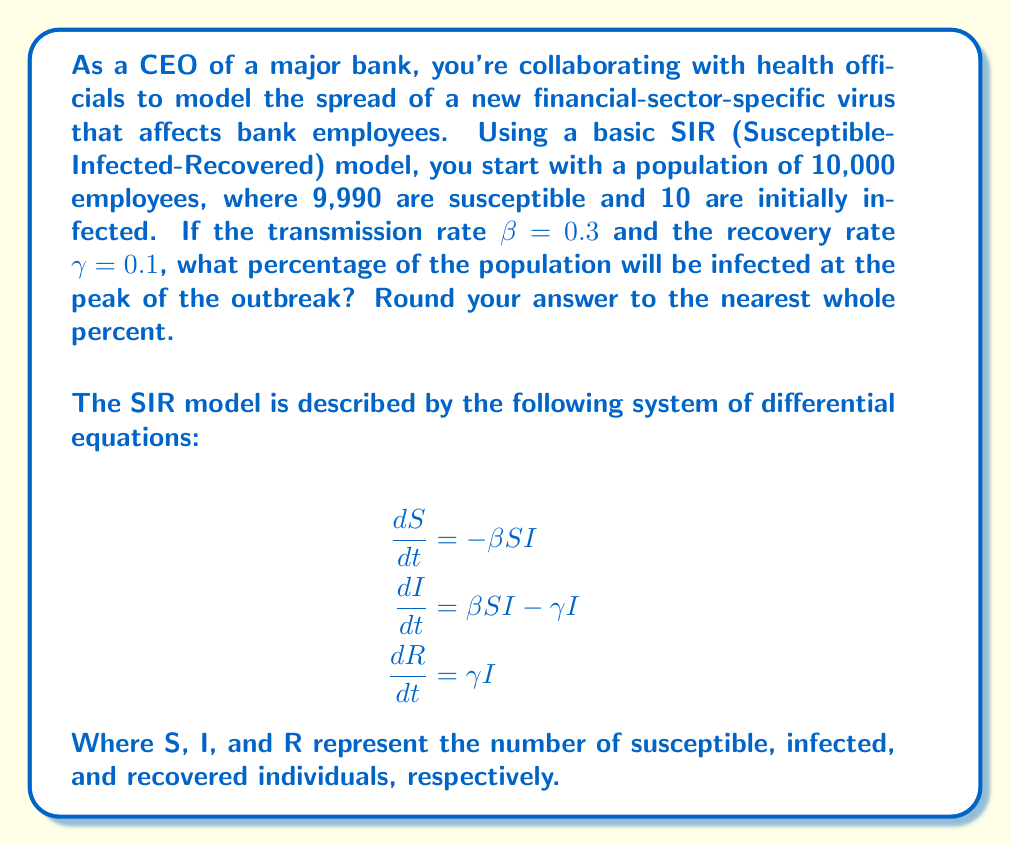Help me with this question. To solve this problem, we'll follow these steps:

1) First, we need to calculate the basic reproduction number R₀:
   $$R_0 = \frac{\beta}{\gamma} = \frac{0.3}{0.1} = 3$$

2) In an SIR model, the peak of the outbreak occurs when the number of susceptible individuals reaches the threshold S_t:
   $$S_t = \frac{N}{R_0} = \frac{10,000}{3} \approx 3,333.33$$

3) At this point, the number of infected individuals is at its maximum. We can calculate this using the conservation of population:
   $$N = S + I + R$$
   $$I_{max} = N - S_t - R$$

4) To find R, we use the fact that at the peak, the rate of change of infected individuals is zero:
   $$\frac{dI}{dt} = \beta SI - \gamma I = 0$$
   $$\beta S_t = \gamma$$
   $$S_t = \frac{\gamma}{\beta} = \frac{0.1}{0.3} \approx 0.3333$$

5) This means that at the peak, 33.33% of the population is susceptible. We can now calculate the percentage that has recovered:
   $$R = N(1 - \frac{1}{R_0} - \frac{1}{R_0}\ln{R_0})$$
   $$R = 10,000(1 - \frac{1}{3} - \frac{1}{3}\ln{3}) \approx 1,035.17$$

6) Now we can calculate I_max:
   $$I_{max} = 10,000 - 3,333.33 - 1,035.17 = 5,631.50$$

7) To get the percentage, we divide by the total population and multiply by 100:
   $$\text{Percentage Infected} = \frac{5,631.50}{10,000} \times 100 \approx 56.32\%$$

8) Rounding to the nearest whole percent gives us 56%.
Answer: 56% 